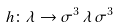Convert formula to latex. <formula><loc_0><loc_0><loc_500><loc_500>h \colon \lambda \to \sigma ^ { 3 } \, \lambda \, \sigma ^ { 3 }</formula> 